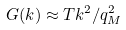Convert formula to latex. <formula><loc_0><loc_0><loc_500><loc_500>G ( k ) \approx T k ^ { 2 } / q _ { M } ^ { 2 }</formula> 